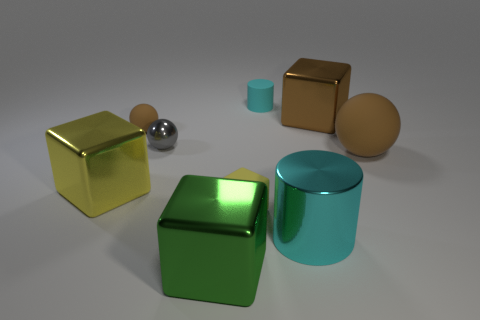Is the small cylinder the same color as the large cylinder?
Provide a succinct answer. Yes. What number of tiny cyan cylinders are behind the brown object that is behind the brown rubber object left of the cyan matte cylinder?
Your answer should be compact. 1. What is the size of the green object?
Keep it short and to the point. Large. What is the material of the green cube that is the same size as the yellow metal block?
Your answer should be very brief. Metal. How many yellow shiny cubes are right of the big cylinder?
Your answer should be very brief. 0. Is the material of the cyan object that is behind the small yellow thing the same as the yellow cube to the left of the big green metallic block?
Provide a short and direct response. No. There is a large metallic thing that is in front of the large cyan shiny thing on the right side of the brown rubber ball that is left of the small yellow matte thing; what shape is it?
Your response must be concise. Cube. The tiny metal thing is what shape?
Your answer should be compact. Sphere. What is the shape of the brown rubber object that is the same size as the brown cube?
Provide a short and direct response. Sphere. How many other things are the same color as the large cylinder?
Your answer should be very brief. 1. 